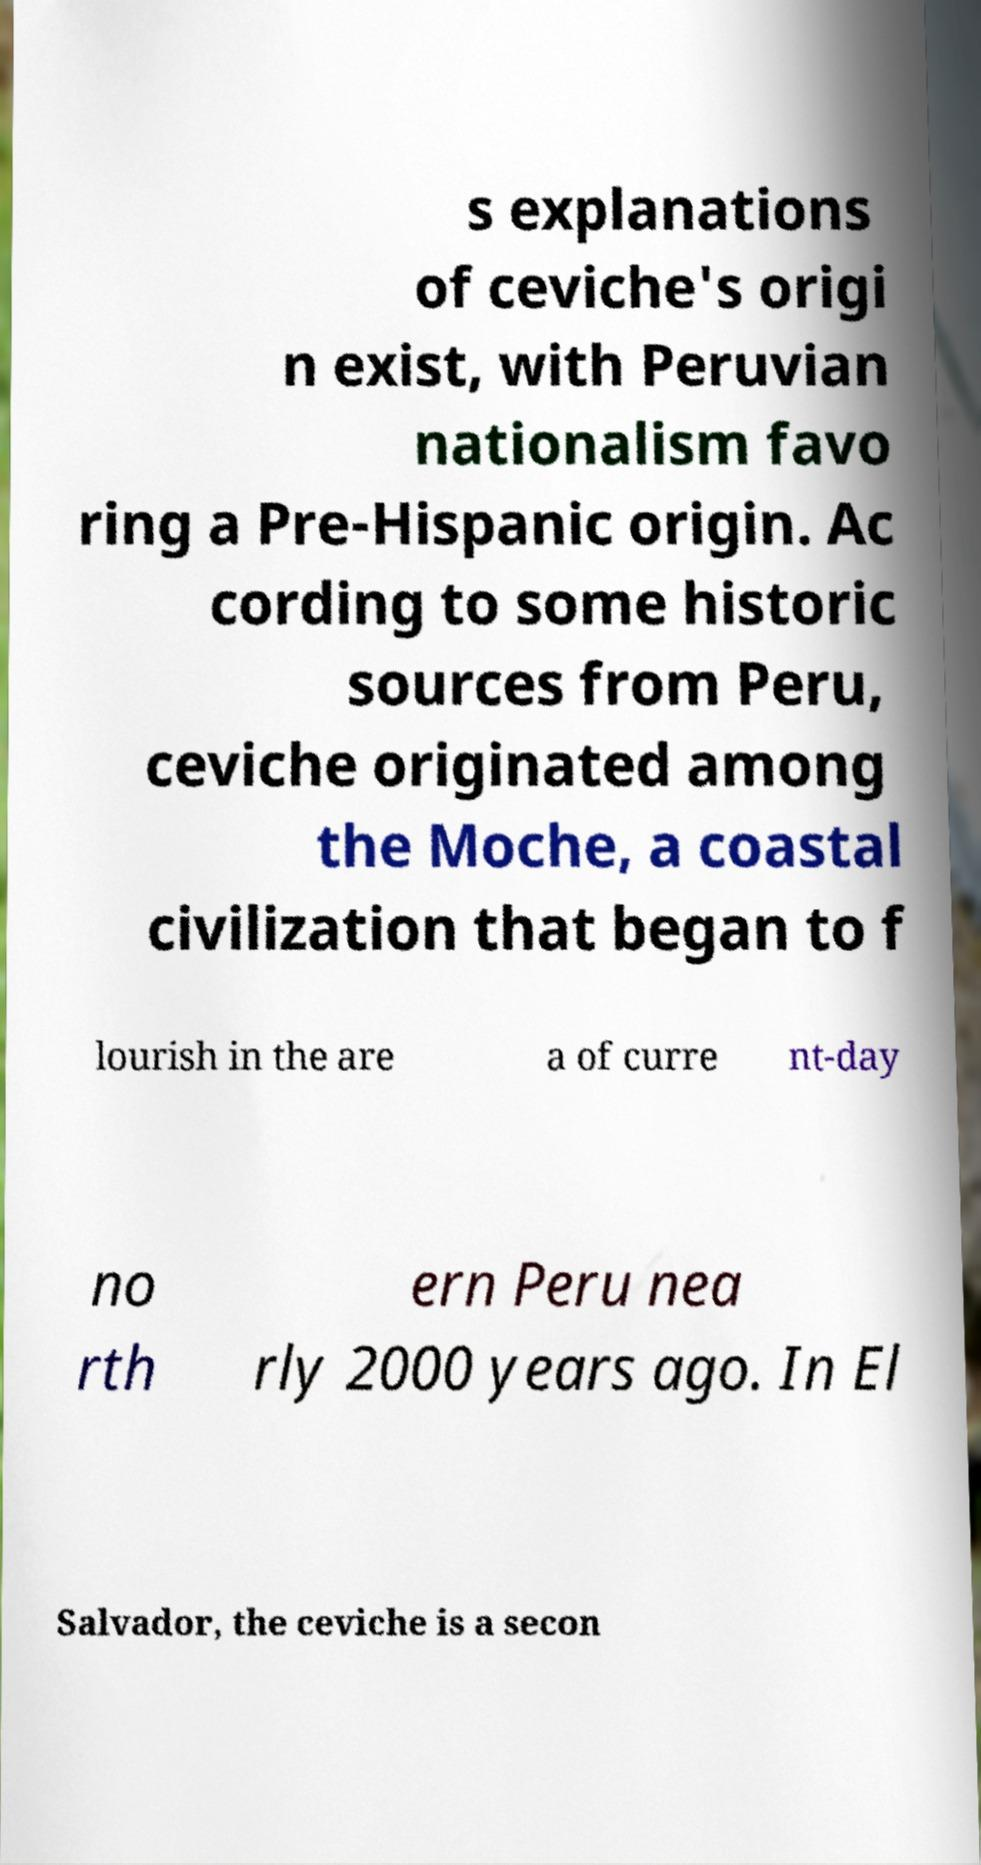Can you accurately transcribe the text from the provided image for me? s explanations of ceviche's origi n exist, with Peruvian nationalism favo ring a Pre-Hispanic origin. Ac cording to some historic sources from Peru, ceviche originated among the Moche, a coastal civilization that began to f lourish in the are a of curre nt-day no rth ern Peru nea rly 2000 years ago. In El Salvador, the ceviche is a secon 